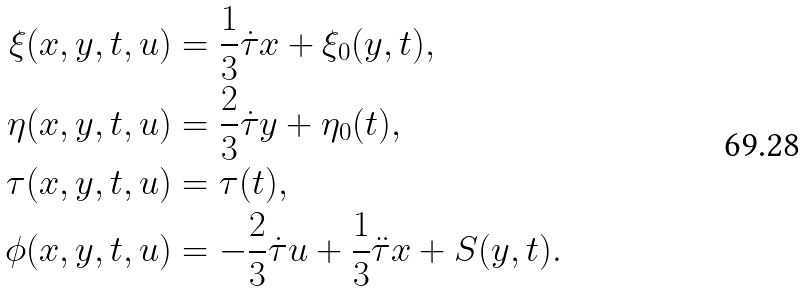Convert formula to latex. <formula><loc_0><loc_0><loc_500><loc_500>\xi ( x , y , t , u ) & = \frac { 1 } { 3 } \dot { \tau } x + \xi _ { 0 } ( y , t ) , \\ \eta ( x , y , t , u ) & = \frac { 2 } { 3 } \dot { \tau } y + \eta _ { 0 } ( t ) , \\ \tau ( x , y , t , u ) & = \tau ( t ) , \\ \phi ( x , y , t , u ) & = - \frac { 2 } { 3 } \dot { \tau } u + \frac { 1 } { 3 } \ddot { \tau } x + S ( y , t ) . \\</formula> 